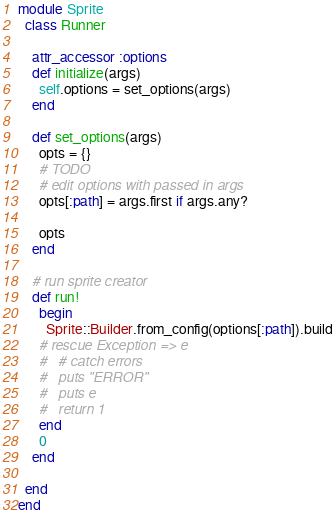<code> <loc_0><loc_0><loc_500><loc_500><_Ruby_>module Sprite
  class Runner

    attr_accessor :options
    def initialize(args)
      self.options = set_options(args)
    end

    def set_options(args)
      opts = {}
      # TODO
      # edit options with passed in args
      opts[:path] = args.first if args.any?

      opts
    end

    # run sprite creator
    def run!
      begin
        Sprite::Builder.from_config(options[:path]).build
      # rescue Exception => e
      #   # catch errors
      #   puts "ERROR"
      #   puts e
      #   return 1
      end
      0
    end

  end
end</code> 